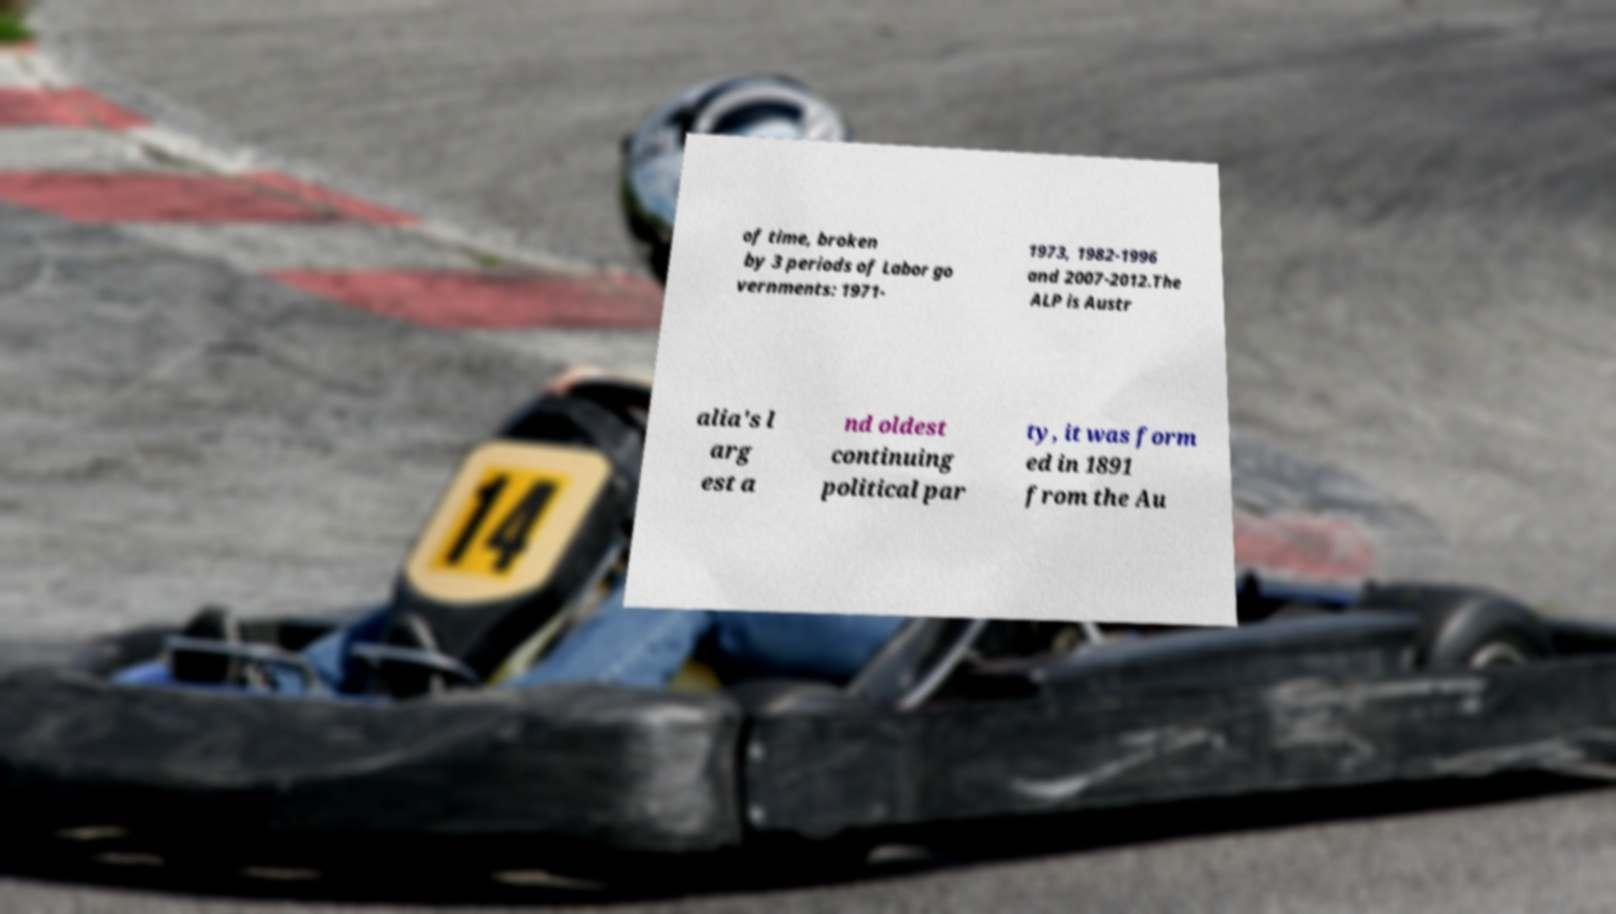I need the written content from this picture converted into text. Can you do that? of time, broken by 3 periods of Labor go vernments: 1971- 1973, 1982-1996 and 2007-2012.The ALP is Austr alia's l arg est a nd oldest continuing political par ty, it was form ed in 1891 from the Au 